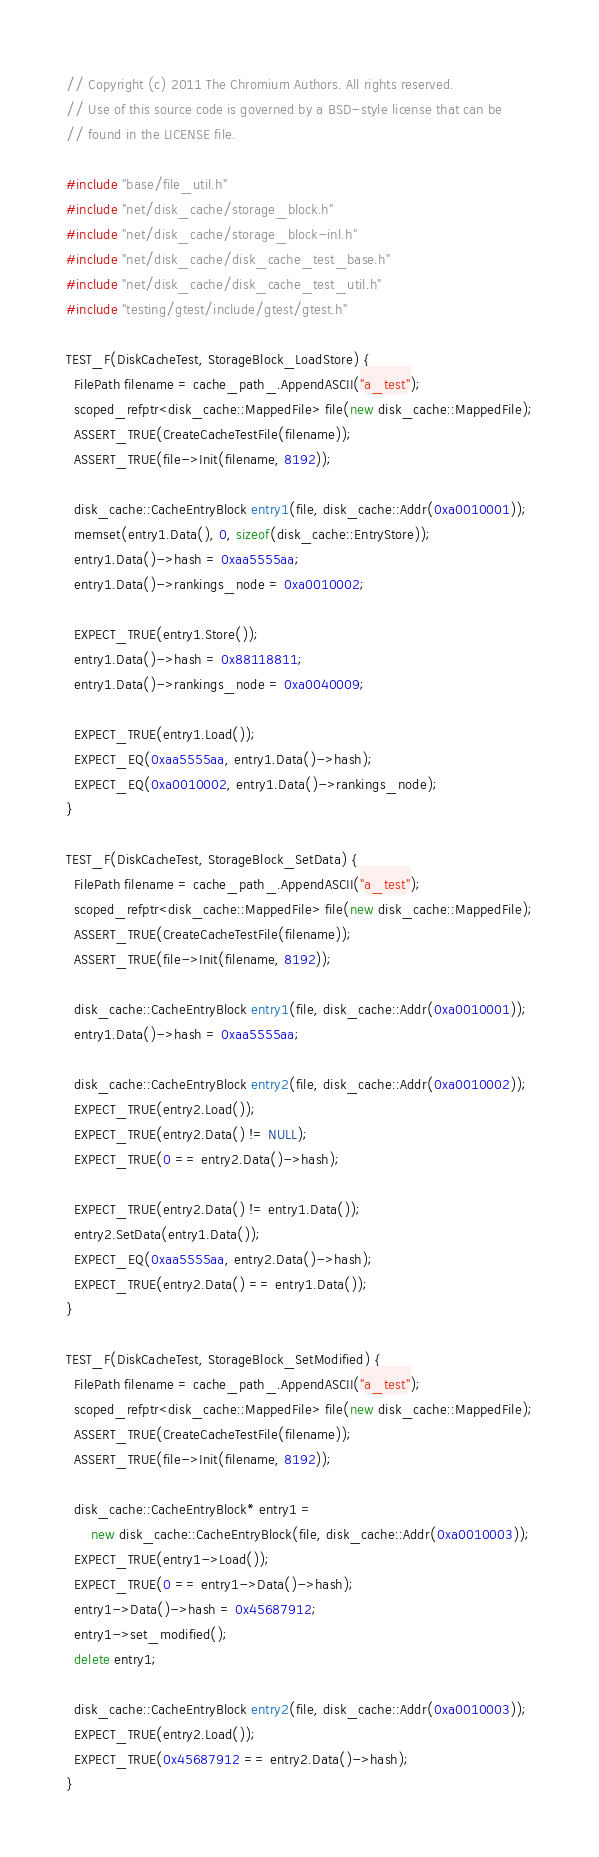<code> <loc_0><loc_0><loc_500><loc_500><_C++_>// Copyright (c) 2011 The Chromium Authors. All rights reserved.
// Use of this source code is governed by a BSD-style license that can be
// found in the LICENSE file.

#include "base/file_util.h"
#include "net/disk_cache/storage_block.h"
#include "net/disk_cache/storage_block-inl.h"
#include "net/disk_cache/disk_cache_test_base.h"
#include "net/disk_cache/disk_cache_test_util.h"
#include "testing/gtest/include/gtest/gtest.h"

TEST_F(DiskCacheTest, StorageBlock_LoadStore) {
  FilePath filename = cache_path_.AppendASCII("a_test");
  scoped_refptr<disk_cache::MappedFile> file(new disk_cache::MappedFile);
  ASSERT_TRUE(CreateCacheTestFile(filename));
  ASSERT_TRUE(file->Init(filename, 8192));

  disk_cache::CacheEntryBlock entry1(file, disk_cache::Addr(0xa0010001));
  memset(entry1.Data(), 0, sizeof(disk_cache::EntryStore));
  entry1.Data()->hash = 0xaa5555aa;
  entry1.Data()->rankings_node = 0xa0010002;

  EXPECT_TRUE(entry1.Store());
  entry1.Data()->hash = 0x88118811;
  entry1.Data()->rankings_node = 0xa0040009;

  EXPECT_TRUE(entry1.Load());
  EXPECT_EQ(0xaa5555aa, entry1.Data()->hash);
  EXPECT_EQ(0xa0010002, entry1.Data()->rankings_node);
}

TEST_F(DiskCacheTest, StorageBlock_SetData) {
  FilePath filename = cache_path_.AppendASCII("a_test");
  scoped_refptr<disk_cache::MappedFile> file(new disk_cache::MappedFile);
  ASSERT_TRUE(CreateCacheTestFile(filename));
  ASSERT_TRUE(file->Init(filename, 8192));

  disk_cache::CacheEntryBlock entry1(file, disk_cache::Addr(0xa0010001));
  entry1.Data()->hash = 0xaa5555aa;

  disk_cache::CacheEntryBlock entry2(file, disk_cache::Addr(0xa0010002));
  EXPECT_TRUE(entry2.Load());
  EXPECT_TRUE(entry2.Data() != NULL);
  EXPECT_TRUE(0 == entry2.Data()->hash);

  EXPECT_TRUE(entry2.Data() != entry1.Data());
  entry2.SetData(entry1.Data());
  EXPECT_EQ(0xaa5555aa, entry2.Data()->hash);
  EXPECT_TRUE(entry2.Data() == entry1.Data());
}

TEST_F(DiskCacheTest, StorageBlock_SetModified) {
  FilePath filename = cache_path_.AppendASCII("a_test");
  scoped_refptr<disk_cache::MappedFile> file(new disk_cache::MappedFile);
  ASSERT_TRUE(CreateCacheTestFile(filename));
  ASSERT_TRUE(file->Init(filename, 8192));

  disk_cache::CacheEntryBlock* entry1 =
      new disk_cache::CacheEntryBlock(file, disk_cache::Addr(0xa0010003));
  EXPECT_TRUE(entry1->Load());
  EXPECT_TRUE(0 == entry1->Data()->hash);
  entry1->Data()->hash = 0x45687912;
  entry1->set_modified();
  delete entry1;

  disk_cache::CacheEntryBlock entry2(file, disk_cache::Addr(0xa0010003));
  EXPECT_TRUE(entry2.Load());
  EXPECT_TRUE(0x45687912 == entry2.Data()->hash);
}
</code> 